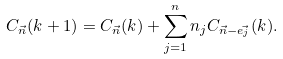Convert formula to latex. <formula><loc_0><loc_0><loc_500><loc_500>C _ { \vec { n } } ( k + 1 ) = C _ { \vec { n } } ( k ) + \sum _ { j = 1 } ^ { n } n _ { j } C _ { \vec { n } - \vec { e _ { j } } } ( k ) .</formula> 